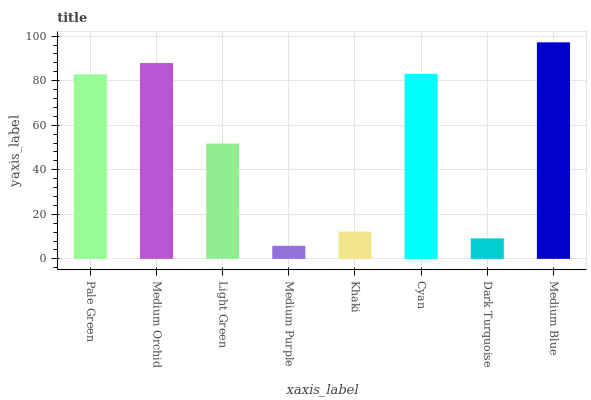Is Medium Blue the maximum?
Answer yes or no. Yes. Is Medium Orchid the minimum?
Answer yes or no. No. Is Medium Orchid the maximum?
Answer yes or no. No. Is Medium Orchid greater than Pale Green?
Answer yes or no. Yes. Is Pale Green less than Medium Orchid?
Answer yes or no. Yes. Is Pale Green greater than Medium Orchid?
Answer yes or no. No. Is Medium Orchid less than Pale Green?
Answer yes or no. No. Is Pale Green the high median?
Answer yes or no. Yes. Is Light Green the low median?
Answer yes or no. Yes. Is Medium Purple the high median?
Answer yes or no. No. Is Cyan the low median?
Answer yes or no. No. 